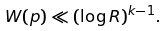Convert formula to latex. <formula><loc_0><loc_0><loc_500><loc_500>W ( p ) \ll ( \log R ) ^ { k - 1 } .</formula> 